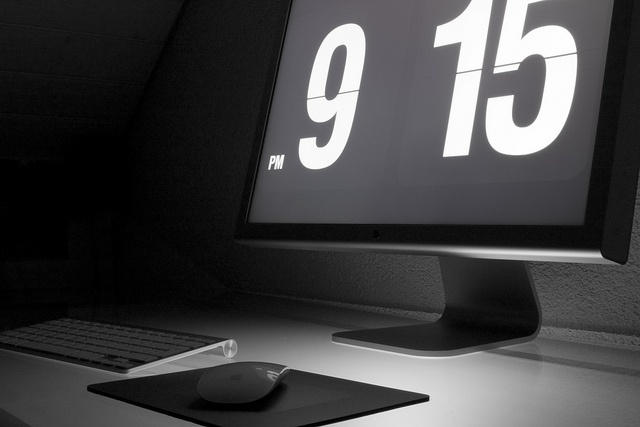Describe the objects in this image and their specific colors. I can see clock in black, gray, white, and darkgray tones, keyboard in black, darkgray, gray, and lightgray tones, and mouse in black, gray, and darkgray tones in this image. 